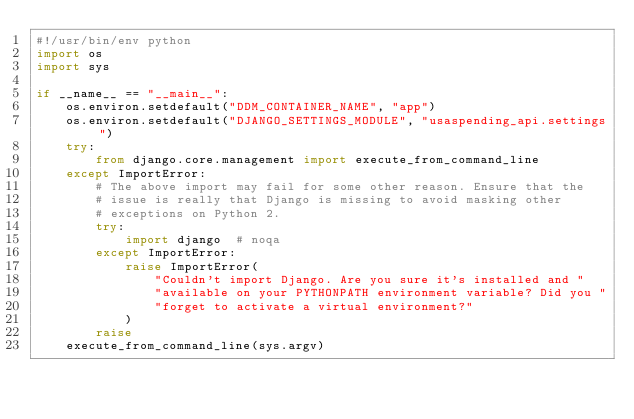<code> <loc_0><loc_0><loc_500><loc_500><_Python_>#!/usr/bin/env python
import os
import sys

if __name__ == "__main__":
    os.environ.setdefault("DDM_CONTAINER_NAME", "app")
    os.environ.setdefault("DJANGO_SETTINGS_MODULE", "usaspending_api.settings")
    try:
        from django.core.management import execute_from_command_line
    except ImportError:
        # The above import may fail for some other reason. Ensure that the
        # issue is really that Django is missing to avoid masking other
        # exceptions on Python 2.
        try:
            import django  # noqa
        except ImportError:
            raise ImportError(
                "Couldn't import Django. Are you sure it's installed and "
                "available on your PYTHONPATH environment variable? Did you "
                "forget to activate a virtual environment?"
            )
        raise
    execute_from_command_line(sys.argv)
</code> 